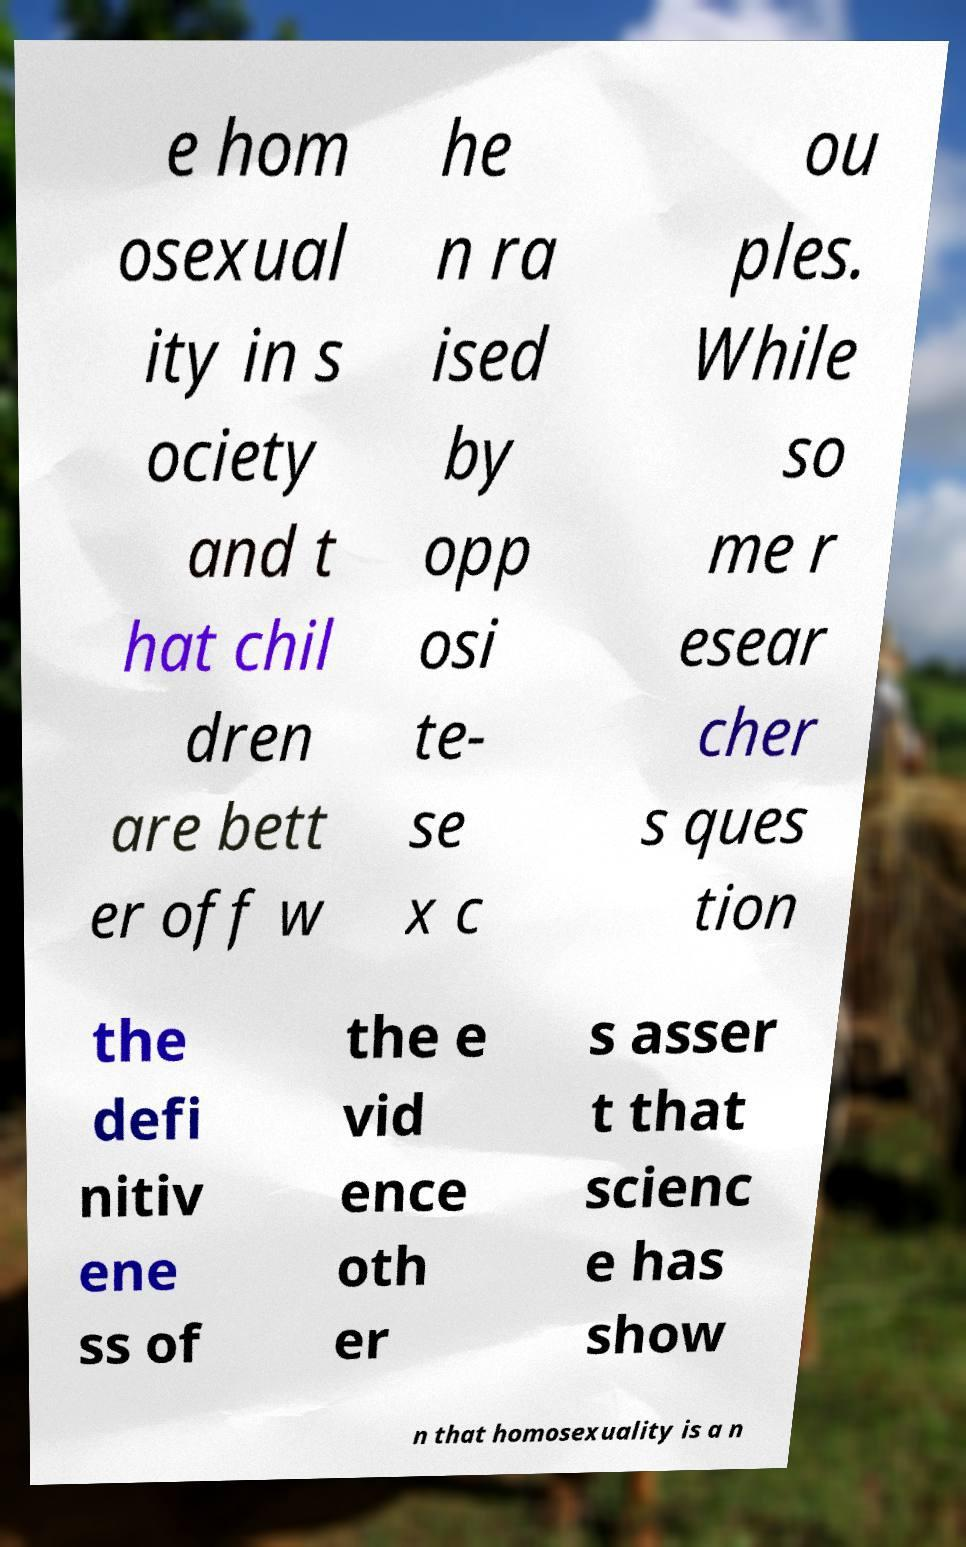Can you read and provide the text displayed in the image?This photo seems to have some interesting text. Can you extract and type it out for me? e hom osexual ity in s ociety and t hat chil dren are bett er off w he n ra ised by opp osi te- se x c ou ples. While so me r esear cher s ques tion the defi nitiv ene ss of the e vid ence oth er s asser t that scienc e has show n that homosexuality is a n 